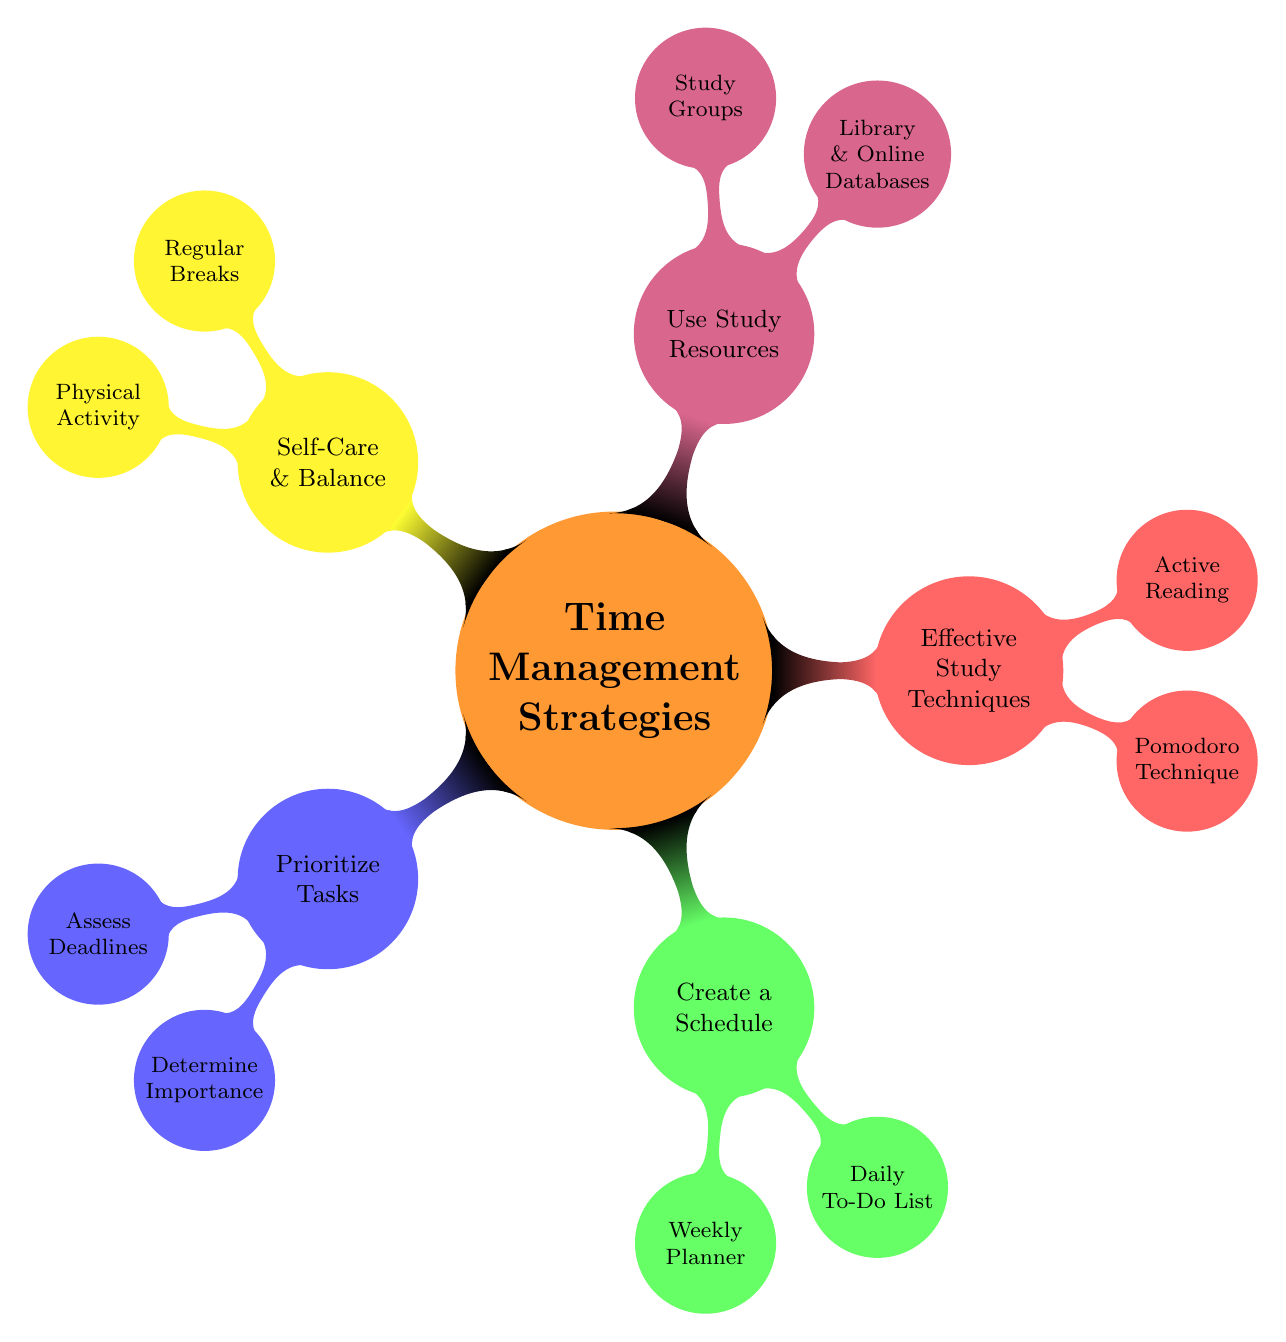What are the main categories in the mind map? The main categories are the five child nodes directly connected to the central node, which include Prioritize Tasks, Create a Schedule, Effective Study Techniques, Use Study Resources, and Self-Care & Balance.
Answer: Prioritize Tasks, Create a Schedule, Effective Study Techniques, Use Study Resources, Self-Care & Balance How many strategies are listed under Effective Study Techniques? There are two child nodes under Effective Study Techniques, namely Pomodoro Technique and Active Reading, indicating a total of two strategies listed.
Answer: 2 Which strategy involves using a planner? The strategy that involves using a planner is found in the Create a Schedule category, specifically under the Weekly Planner node.
Answer: Weekly Planner What is the relationship between Self-Care & Balance and Regular Breaks? Regular Breaks is a direct sub-node under the Self-Care & Balance category, indicating that it is one of the strategies to maintain balance in managing coursework.
Answer: Direct sub-node If a student uses the Library & Online Databases, which category does this strategy belong to? Library & Online Databases is a sub-node under the Use Study Resources category, describing a specific study resource available to students in their coursework.
Answer: Use Study Resources What technique can help prevent burnout according to the mind map? The technique that can help prevent burnout is Regular Breaks, which is identified as a strategy within the Self-Care & Balance category.
Answer: Regular Breaks How does the Pomodoro Technique function conceptually, based on the mind map? The Pomodoro Technique works by breaking study time into intervals, which are complemented by short breaks, promoting focus and refreshment during study sessions.
Answer: Break study time into intervals with short breaks Which two nodes are found directly under the Use Study Resources category? The two nodes directly found under Use Study Resources are Library & Online Databases and Study Groups, highlighting options for collaborative and independent study resources.
Answer: Library & Online Databases, Study Groups 